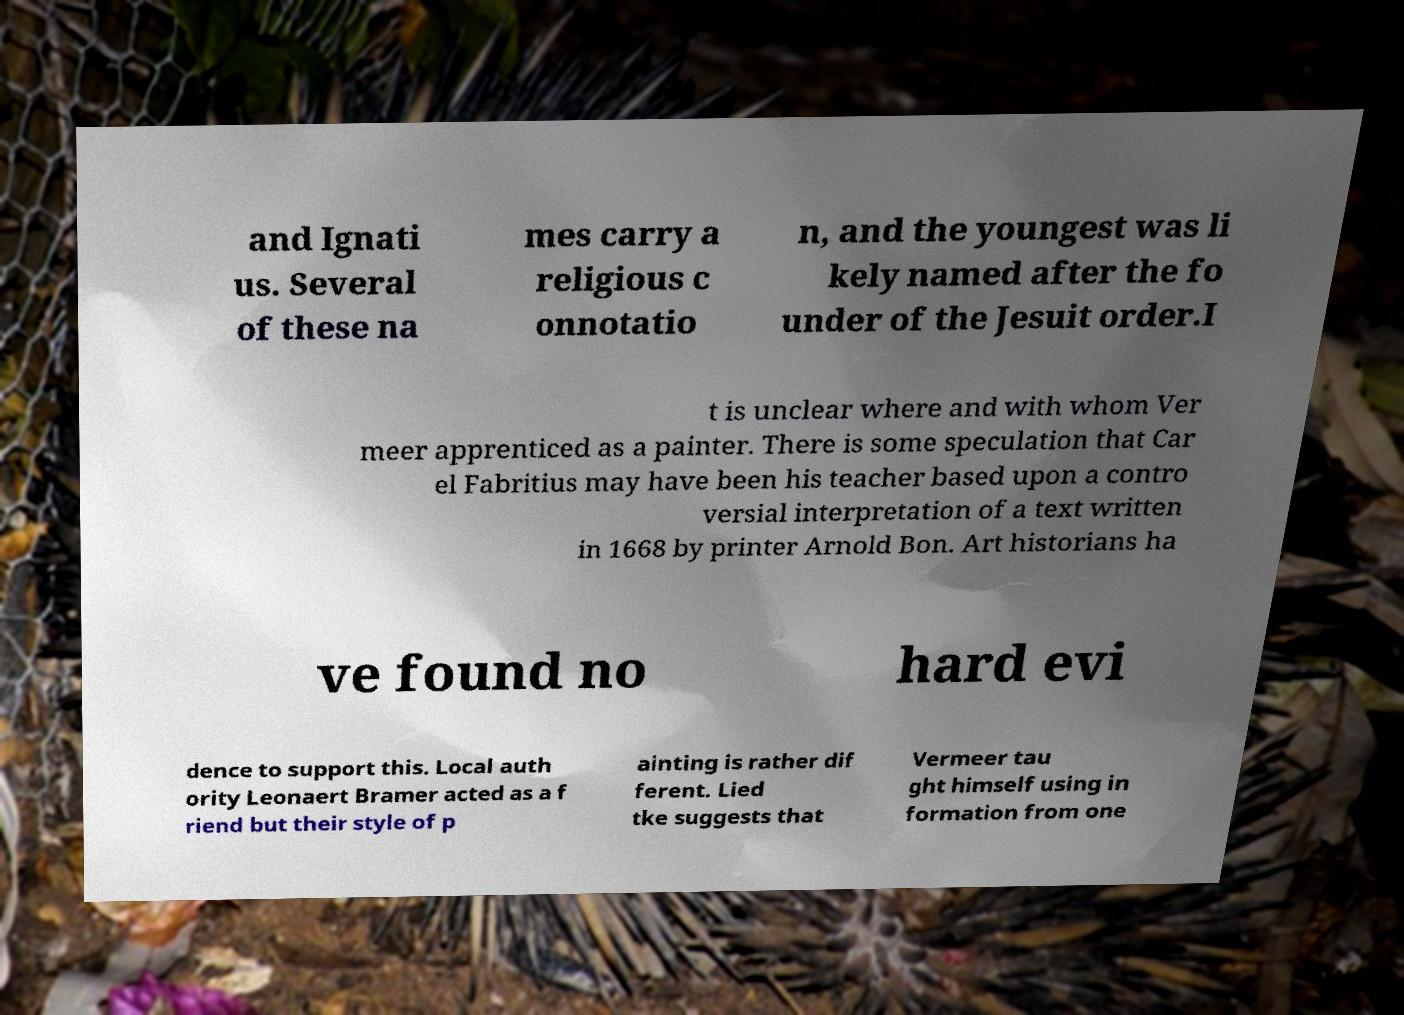For documentation purposes, I need the text within this image transcribed. Could you provide that? and Ignati us. Several of these na mes carry a religious c onnotatio n, and the youngest was li kely named after the fo under of the Jesuit order.I t is unclear where and with whom Ver meer apprenticed as a painter. There is some speculation that Car el Fabritius may have been his teacher based upon a contro versial interpretation of a text written in 1668 by printer Arnold Bon. Art historians ha ve found no hard evi dence to support this. Local auth ority Leonaert Bramer acted as a f riend but their style of p ainting is rather dif ferent. Lied tke suggests that Vermeer tau ght himself using in formation from one 